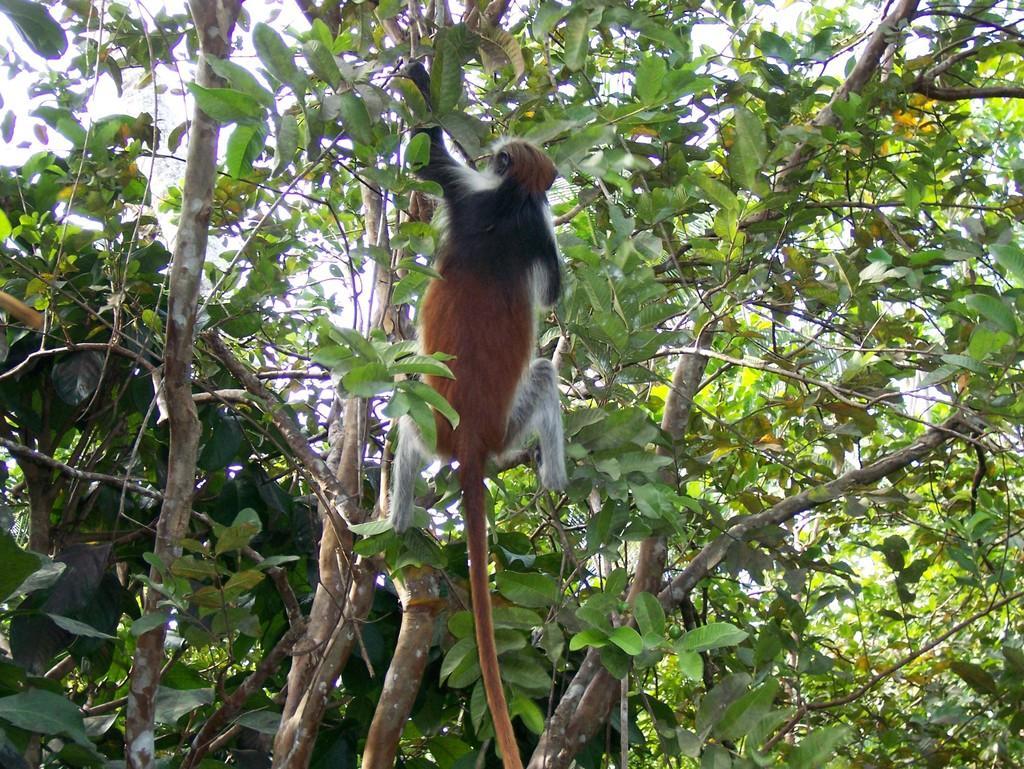Please provide a concise description of this image. In this image we can see a monkey on the tree, also we can see the sky. 